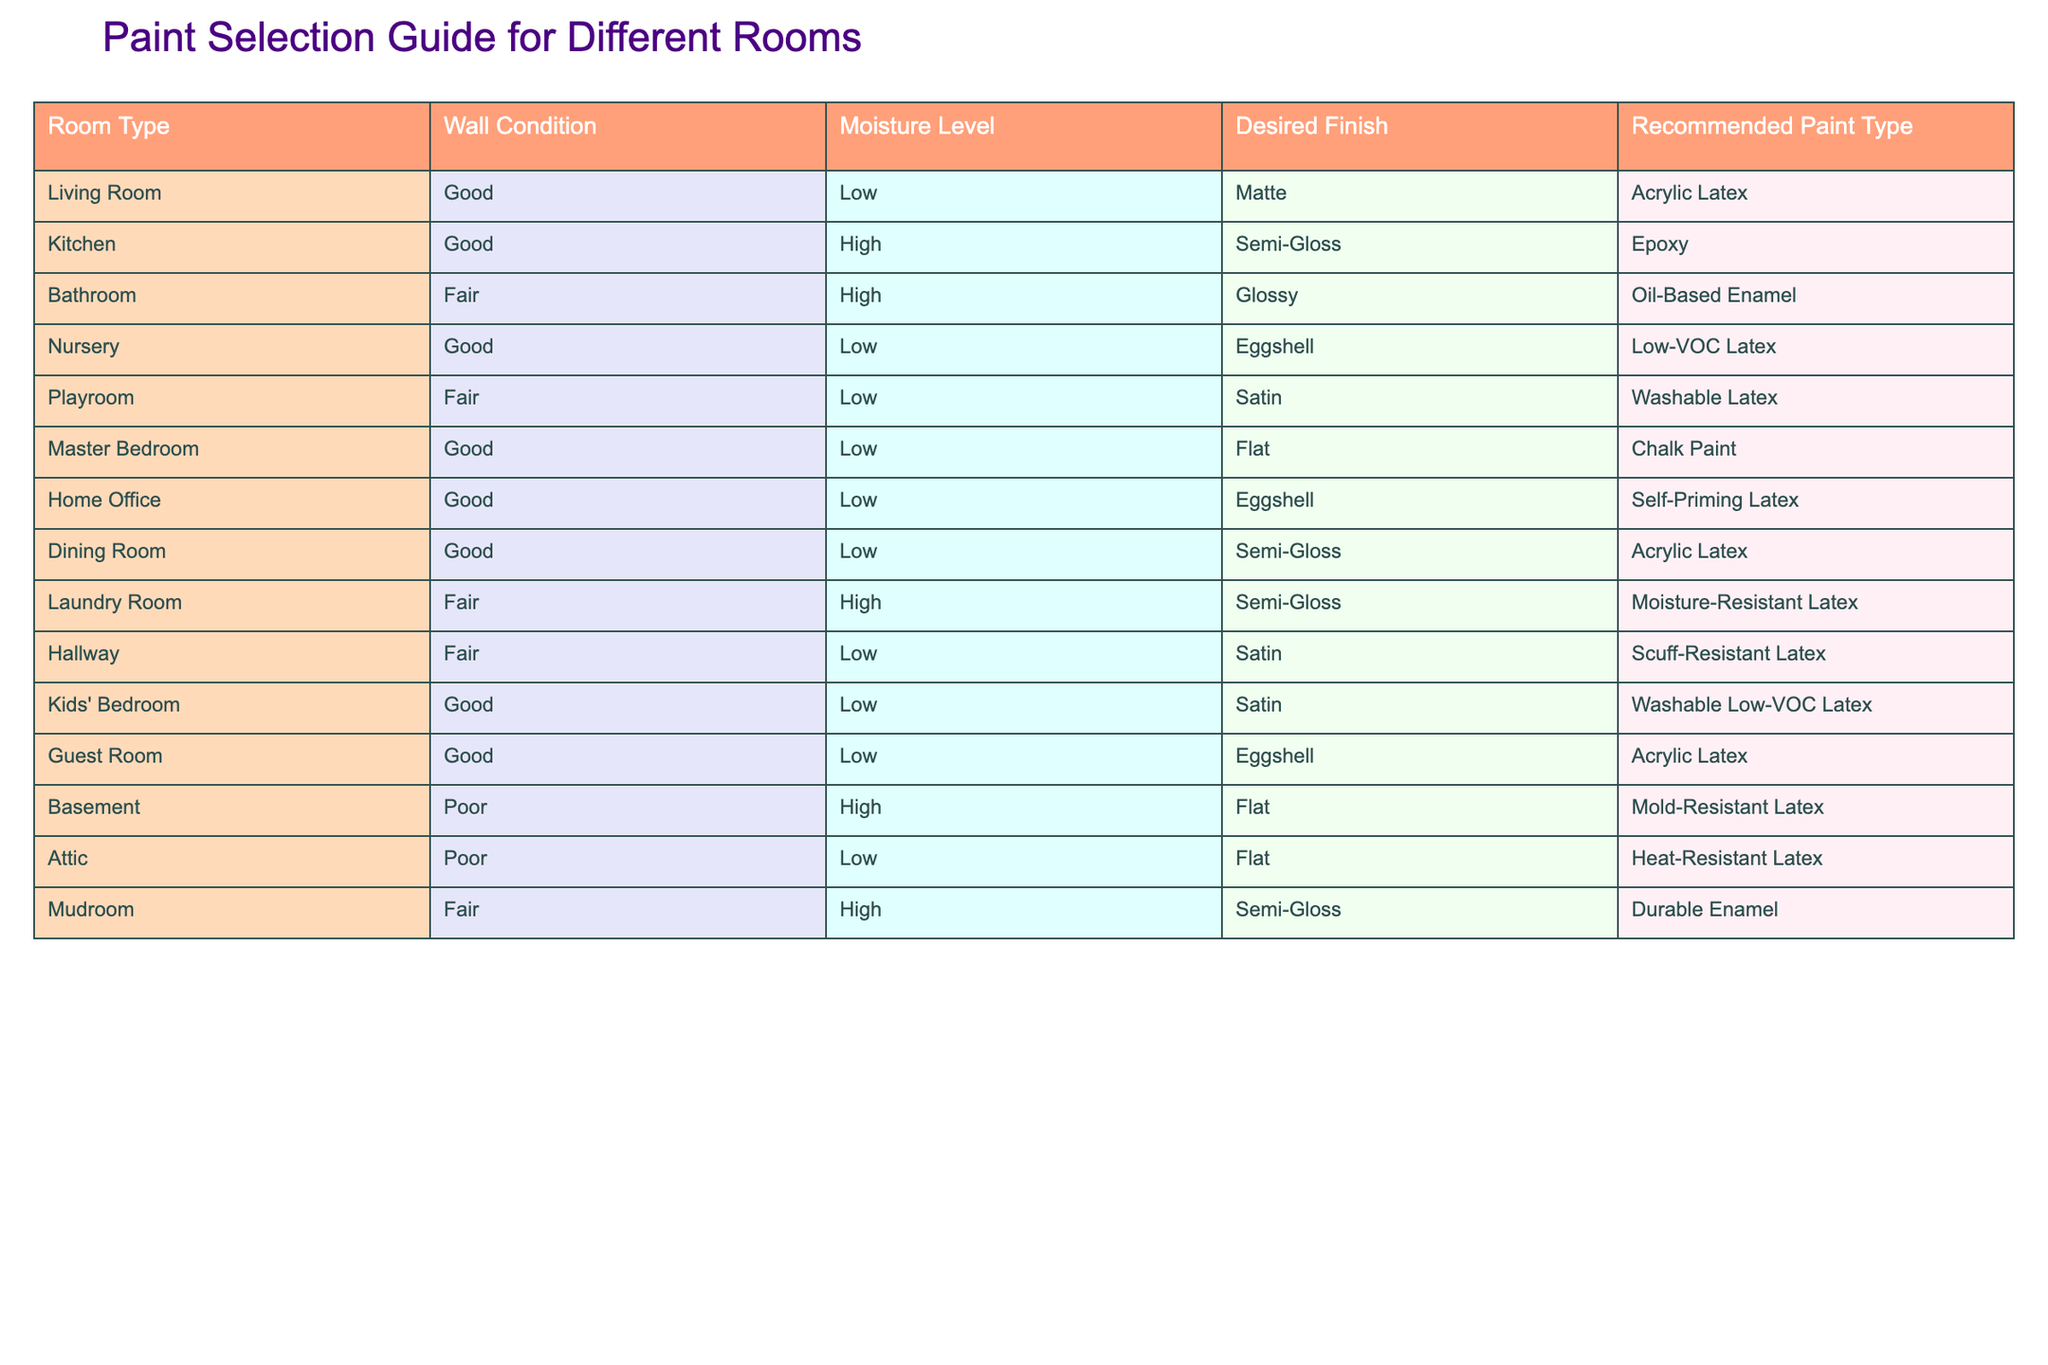What type of paint is recommended for the kitchen? According to the table, the recommended paint type for the kitchen is Epoxy, which is suitable for areas with high moisture levels and a desired semi-gloss finish.
Answer: Epoxy Are the kids' bedroom and playroom recommended to use the same type of paint? The kids' bedroom is recommended to use Washable Low-VOC Latex, while the playroom uses Washable Latex. Therefore, they are not the same type of paint, although both are washable.
Answer: No What is the recommended paint for a bathroom with high moisture and glossy finish? For the bathroom, with high moisture levels and a glossy finish, the table recommends Oil-Based Enamel as the appropriate paint type.
Answer: Oil-Based Enamel Which room has the recommended paint type of Mold-Resistant Latex? The basement is specified in the table to use Mold-Resistant Latex due to its poor wall condition and high moisture level.
Answer: Basement Which rooms have a fair wall condition and are recommended to use a semi-gloss finish? The kitchen, laundry room, and mudroom are all listed with fair wall conditions and a recommended semi-gloss finish. Thus, the answer includes these three rooms.
Answer: Kitchen, Laundry Room, Mudroom How many rooms are recommended to use Low-VOC paint? The nursery and kids’ bedroom are both recommended Low-VOC paint types. When counting, there are two rooms that meet this criterion.
Answer: 2 Is there a type of paint that is recommended for rooms with a high moisture level that is not gloss finish? Yes, the laundry room is recommended to use a semi-gloss paint type while also accommodating a high moisture level. Thus, it doesn’t fall under gloss finish even though it is semi-gloss.
Answer: Yes What type of paint is used in the master bedroom? Based on the table, the master bedroom is recommended to use Chalk Paint, which is suitable for a flat finish on good wall conditions.
Answer: Chalk Paint What paint is recommended for a hallway with fair wall condition? The table shows that the hallway, which has a fair wall condition, is recommended to use Scuff-Resistant Latex with a satin finish.
Answer: Scuff-Resistant Latex 